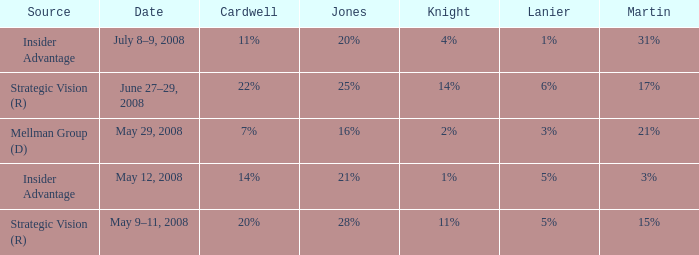Who is the cardwell individual with a knight level of 1% and an insider benefit? 14%. 